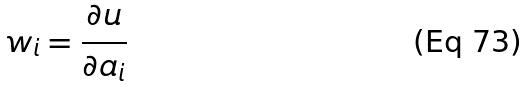Convert formula to latex. <formula><loc_0><loc_0><loc_500><loc_500>w _ { i } = \frac { \partial u } { \partial a _ { i } }</formula> 